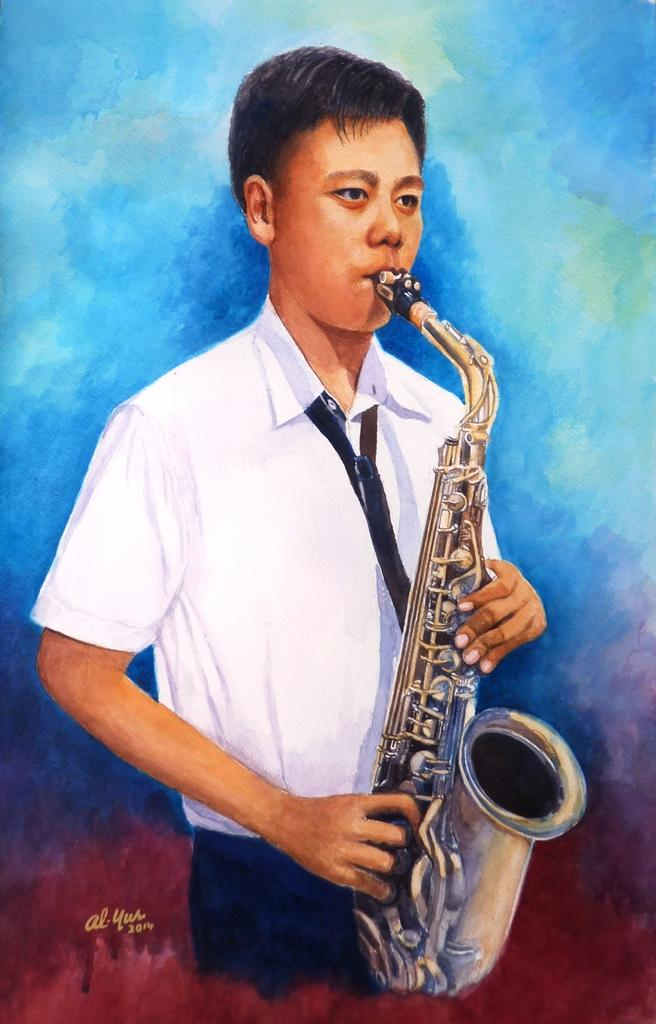What is the main subject of the image? There is a painting in the image. What is the painting depicting? The painting depicts a man playing a trumpet. What color is the background of the painting? The background of the painting is blue. What type of table is visible in the image? There is no table present in the image; it only features a painting. What color is the silverware on the table in the image? There is no table or silverware present in the image. 